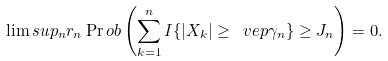<formula> <loc_0><loc_0><loc_500><loc_500>\lim s u p _ { n } r _ { n } \Pr o b \left ( \sum _ { k = 1 } ^ { n } I \{ | X _ { k } | \geq \ v e p \gamma _ { n } \} \geq J _ { n } \right ) = 0 .</formula> 